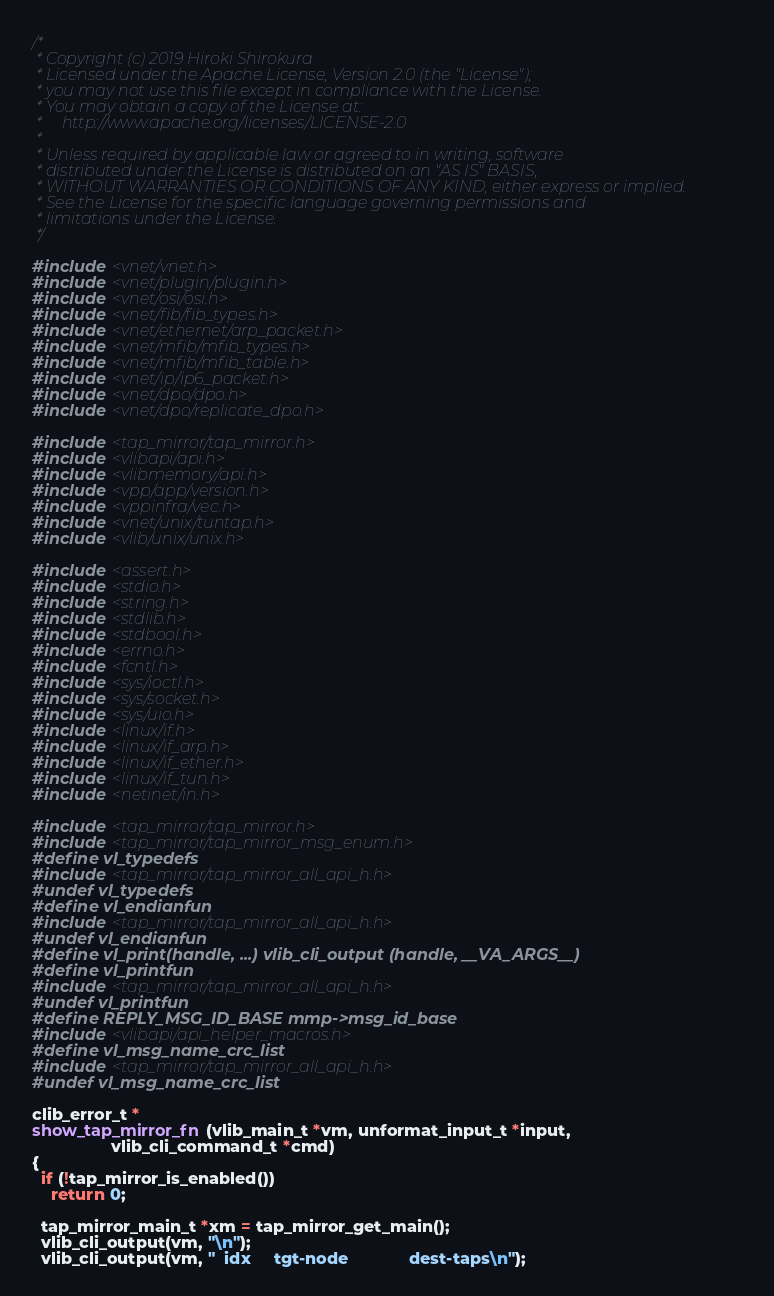Convert code to text. <code><loc_0><loc_0><loc_500><loc_500><_C_>/*
 * Copyright (c) 2019 Hiroki Shirokura
 * Licensed under the Apache License, Version 2.0 (the "License");
 * you may not use this file except in compliance with the License.
 * You may obtain a copy of the License at:
 *     http://www.apache.org/licenses/LICENSE-2.0
 *
 * Unless required by applicable law or agreed to in writing, software
 * distributed under the License is distributed on an "AS IS" BASIS,
 * WITHOUT WARRANTIES OR CONDITIONS OF ANY KIND, either express or implied.
 * See the License for the specific language governing permissions and
 * limitations under the License.
 */

#include <vnet/vnet.h>
#include <vnet/plugin/plugin.h>
#include <vnet/osi/osi.h>
#include <vnet/fib/fib_types.h>
#include <vnet/ethernet/arp_packet.h>
#include <vnet/mfib/mfib_types.h>
#include <vnet/mfib/mfib_table.h>
#include <vnet/ip/ip6_packet.h>
#include <vnet/dpo/dpo.h>
#include <vnet/dpo/replicate_dpo.h>

#include <tap_mirror/tap_mirror.h>
#include <vlibapi/api.h>
#include <vlibmemory/api.h>
#include <vpp/app/version.h>
#include <vppinfra/vec.h>
#include <vnet/unix/tuntap.h>
#include <vlib/unix/unix.h>

#include <assert.h>
#include <stdio.h>
#include <string.h>
#include <stdlib.h>
#include <stdbool.h>
#include <errno.h>
#include <fcntl.h>
#include <sys/ioctl.h>
#include <sys/socket.h>
#include <sys/uio.h>
#include <linux/if.h>
#include <linux/if_arp.h>
#include <linux/if_ether.h>
#include <linux/if_tun.h>
#include <netinet/in.h>

#include <tap_mirror/tap_mirror.h>
#include <tap_mirror/tap_mirror_msg_enum.h>
#define vl_typedefs
#include <tap_mirror/tap_mirror_all_api_h.h>
#undef vl_typedefs
#define vl_endianfun
#include <tap_mirror/tap_mirror_all_api_h.h>
#undef vl_endianfun
#define vl_print(handle, ...) vlib_cli_output (handle, __VA_ARGS__)
#define vl_printfun
#include <tap_mirror/tap_mirror_all_api_h.h>
#undef vl_printfun
#define REPLY_MSG_ID_BASE mmp->msg_id_base
#include <vlibapi/api_helper_macros.h>
#define vl_msg_name_crc_list
#include <tap_mirror/tap_mirror_all_api_h.h>
#undef vl_msg_name_crc_list

clib_error_t *
show_tap_mirror_fn (vlib_main_t *vm, unformat_input_t *input,
                 vlib_cli_command_t *cmd)
{
  if (!tap_mirror_is_enabled())
    return 0;

  tap_mirror_main_t *xm = tap_mirror_get_main();
  vlib_cli_output(vm, "\n");
  vlib_cli_output(vm, "  idx     tgt-node             dest-taps\n");</code> 